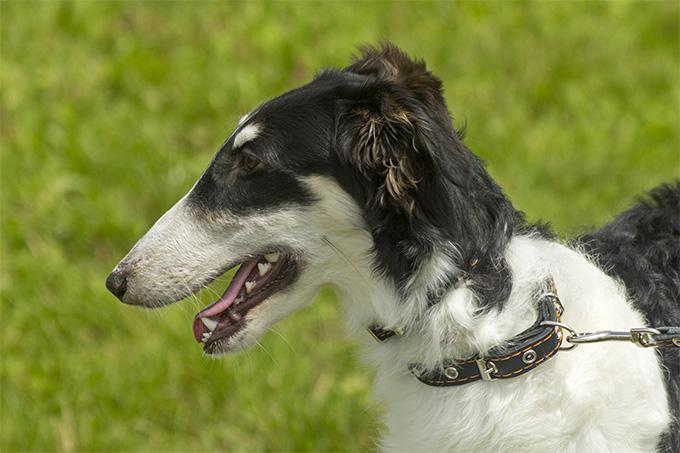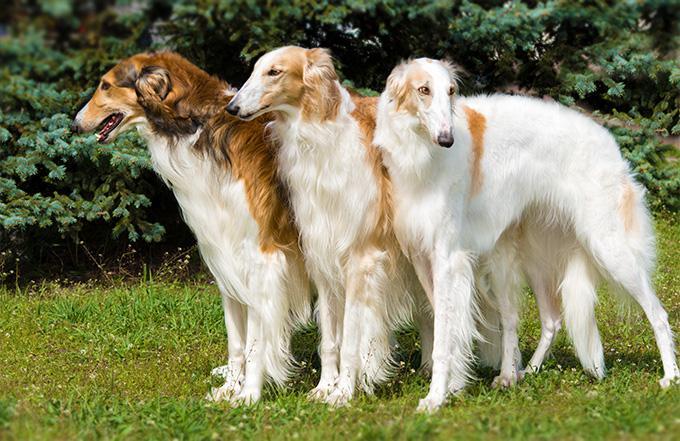The first image is the image on the left, the second image is the image on the right. Considering the images on both sides, is "The dog on the right is white with black spots." valid? Answer yes or no. No. 